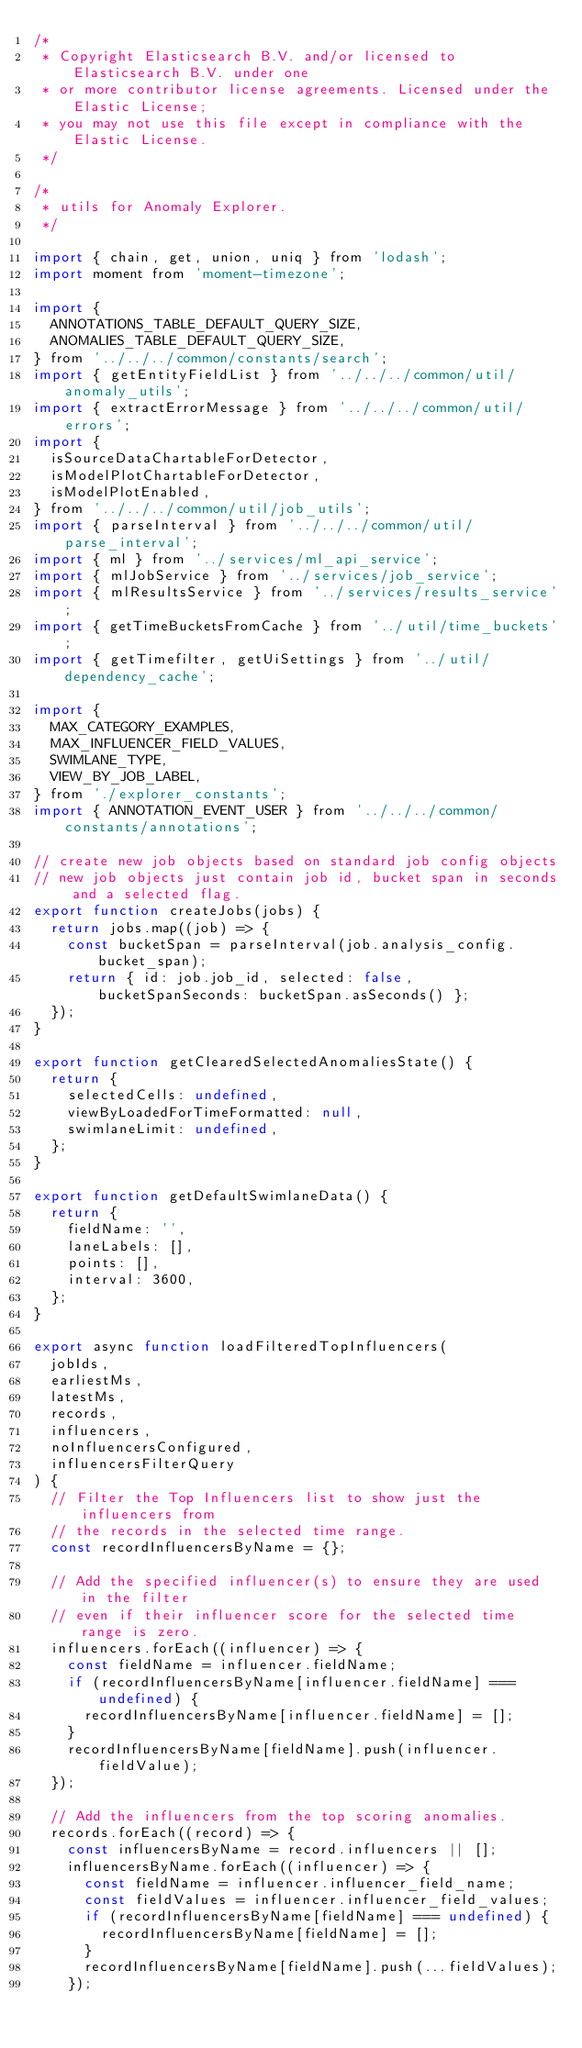Convert code to text. <code><loc_0><loc_0><loc_500><loc_500><_JavaScript_>/*
 * Copyright Elasticsearch B.V. and/or licensed to Elasticsearch B.V. under one
 * or more contributor license agreements. Licensed under the Elastic License;
 * you may not use this file except in compliance with the Elastic License.
 */

/*
 * utils for Anomaly Explorer.
 */

import { chain, get, union, uniq } from 'lodash';
import moment from 'moment-timezone';

import {
  ANNOTATIONS_TABLE_DEFAULT_QUERY_SIZE,
  ANOMALIES_TABLE_DEFAULT_QUERY_SIZE,
} from '../../../common/constants/search';
import { getEntityFieldList } from '../../../common/util/anomaly_utils';
import { extractErrorMessage } from '../../../common/util/errors';
import {
  isSourceDataChartableForDetector,
  isModelPlotChartableForDetector,
  isModelPlotEnabled,
} from '../../../common/util/job_utils';
import { parseInterval } from '../../../common/util/parse_interval';
import { ml } from '../services/ml_api_service';
import { mlJobService } from '../services/job_service';
import { mlResultsService } from '../services/results_service';
import { getTimeBucketsFromCache } from '../util/time_buckets';
import { getTimefilter, getUiSettings } from '../util/dependency_cache';

import {
  MAX_CATEGORY_EXAMPLES,
  MAX_INFLUENCER_FIELD_VALUES,
  SWIMLANE_TYPE,
  VIEW_BY_JOB_LABEL,
} from './explorer_constants';
import { ANNOTATION_EVENT_USER } from '../../../common/constants/annotations';

// create new job objects based on standard job config objects
// new job objects just contain job id, bucket span in seconds and a selected flag.
export function createJobs(jobs) {
  return jobs.map((job) => {
    const bucketSpan = parseInterval(job.analysis_config.bucket_span);
    return { id: job.job_id, selected: false, bucketSpanSeconds: bucketSpan.asSeconds() };
  });
}

export function getClearedSelectedAnomaliesState() {
  return {
    selectedCells: undefined,
    viewByLoadedForTimeFormatted: null,
    swimlaneLimit: undefined,
  };
}

export function getDefaultSwimlaneData() {
  return {
    fieldName: '',
    laneLabels: [],
    points: [],
    interval: 3600,
  };
}

export async function loadFilteredTopInfluencers(
  jobIds,
  earliestMs,
  latestMs,
  records,
  influencers,
  noInfluencersConfigured,
  influencersFilterQuery
) {
  // Filter the Top Influencers list to show just the influencers from
  // the records in the selected time range.
  const recordInfluencersByName = {};

  // Add the specified influencer(s) to ensure they are used in the filter
  // even if their influencer score for the selected time range is zero.
  influencers.forEach((influencer) => {
    const fieldName = influencer.fieldName;
    if (recordInfluencersByName[influencer.fieldName] === undefined) {
      recordInfluencersByName[influencer.fieldName] = [];
    }
    recordInfluencersByName[fieldName].push(influencer.fieldValue);
  });

  // Add the influencers from the top scoring anomalies.
  records.forEach((record) => {
    const influencersByName = record.influencers || [];
    influencersByName.forEach((influencer) => {
      const fieldName = influencer.influencer_field_name;
      const fieldValues = influencer.influencer_field_values;
      if (recordInfluencersByName[fieldName] === undefined) {
        recordInfluencersByName[fieldName] = [];
      }
      recordInfluencersByName[fieldName].push(...fieldValues);
    });</code> 